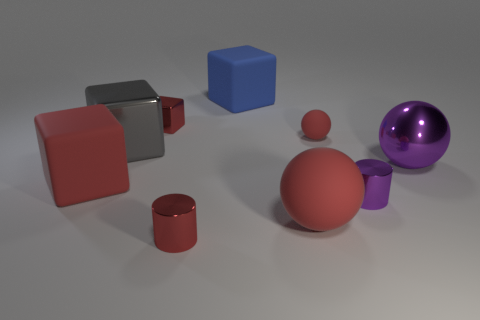Subtract 1 blocks. How many blocks are left? 3 Subtract all cyan balls. Subtract all yellow cylinders. How many balls are left? 3 Add 1 cubes. How many objects exist? 10 Subtract all cubes. How many objects are left? 5 Add 2 tiny purple metallic things. How many tiny purple metallic things exist? 3 Subtract 0 yellow cylinders. How many objects are left? 9 Subtract all small blue blocks. Subtract all rubber spheres. How many objects are left? 7 Add 5 big red matte balls. How many big red matte balls are left? 6 